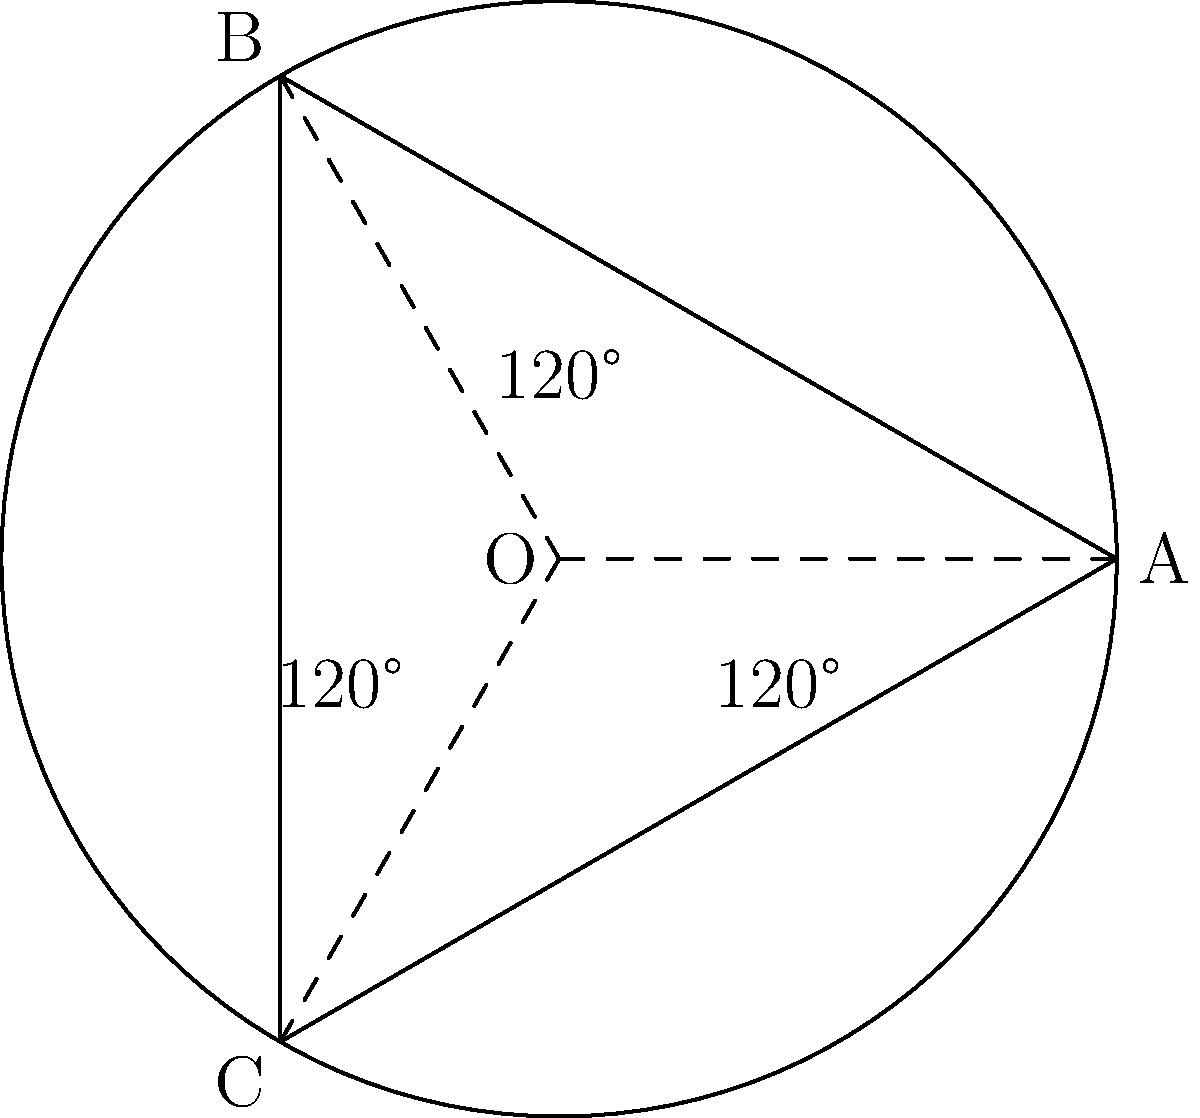In a traditional flamenco performance, a dancer's circular skirt forms a perfect circle when spinning. If the skirt creates three equal segments as shown in the diagram, what is the central angle formed by each segment? To solve this problem, let's follow these steps:

1. Observe that the circle is divided into three equal parts by lines OA, OB, and OC.

2. In a circle, there are 360° in total.

3. Since the circle is divided into three equal parts, we can calculate the central angle for each segment:

   $$\text{Central Angle} = \frac{\text{Total angle of the circle}}{\text{Number of equal segments}}$$

4. Substituting the values:

   $$\text{Central Angle} = \frac{360°}{3} = 120°$$

5. This result is confirmed by the diagram, which shows 120° angles between each pair of radii.

The central angle of 120° represents the angle formed by the flamenco skirt as it spins, creating three equal segments. This formation is crucial in flamenco performances, as it allows the dancer to create dramatic visual effects with the skirt's movement.
Answer: 120° 